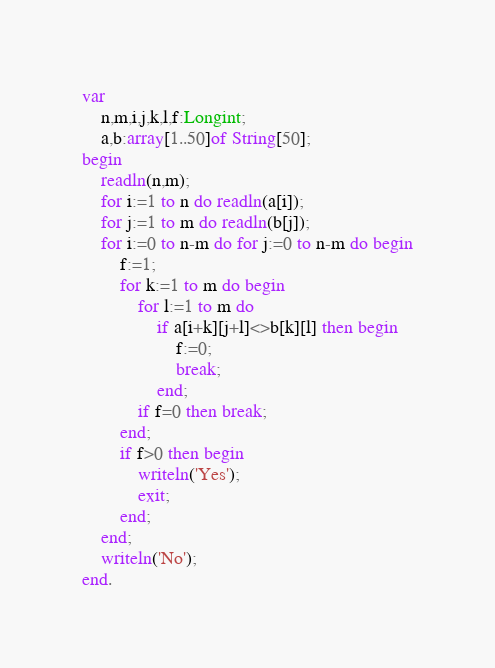Convert code to text. <code><loc_0><loc_0><loc_500><loc_500><_Pascal_>var
	n,m,i,j,k,l,f:Longint;
	a,b:array[1..50]of String[50];
begin
	readln(n,m);
	for i:=1 to n do readln(a[i]);
	for j:=1 to m do readln(b[j]);
	for i:=0 to n-m do for j:=0 to n-m do begin
		f:=1;
		for k:=1 to m do begin
			for l:=1 to m do
				if a[i+k][j+l]<>b[k][l] then begin
					f:=0;
					break;
				end;
			if f=0 then break;
		end;
		if f>0 then begin
			writeln('Yes');
			exit;
		end;
	end;
	writeln('No');
end.
</code> 